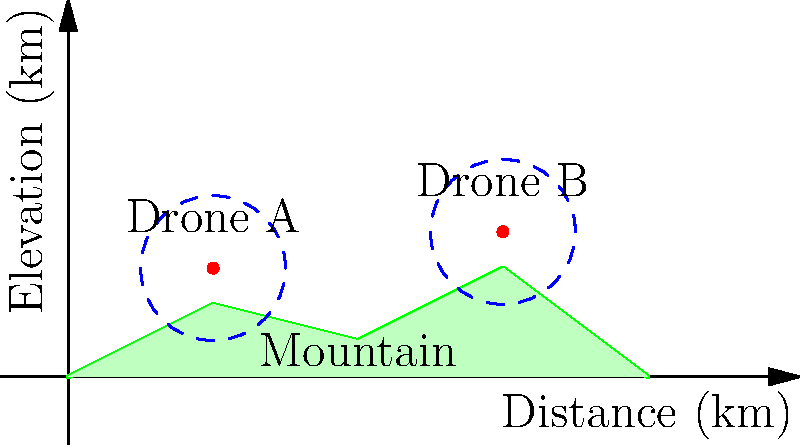In the diagram above, two drones (A and B) are deployed for disaster response over varying terrain. Each drone has a communication range of 10 km. What is the minimum number of additional drones needed to establish a continuous communication link between Drone A and Drone B, assuming drones can only communicate within their range and clear line of sight? To solve this problem, we need to analyze the terrain and drone positions:

1. Observe that Drone A and Drone B are separated by a mountain peak.
2. The mountain obstructs the line of sight between the two drones, preventing direct communication.
3. We need to place additional drones to create a relay network around or over the mountain.
4. Each drone has a 10 km range, represented by the dashed circles.
5. To maintain a continuous link, each drone must be within range of at least one other drone.
6. The most efficient placement would be:
   a. One drone on top of the mountain peak (around 40 km mark)
   b. This drone would be within range of both Drone A and Drone B
7. With this single additional drone, we create a relay network: A → New Drone → B

Therefore, the minimum number of additional drones needed is 1.
Answer: 1 